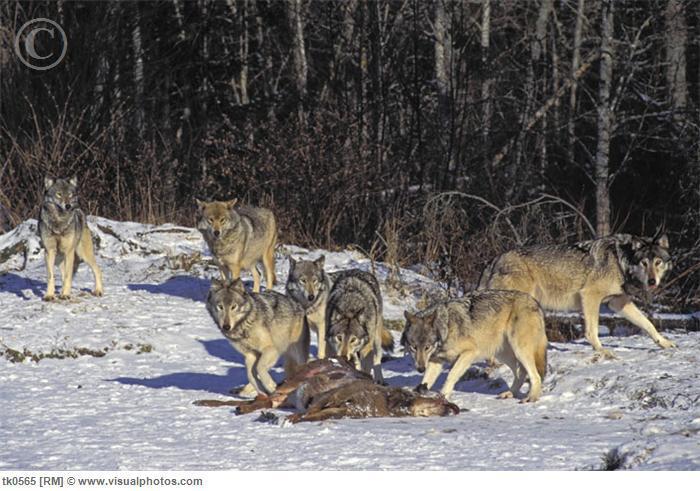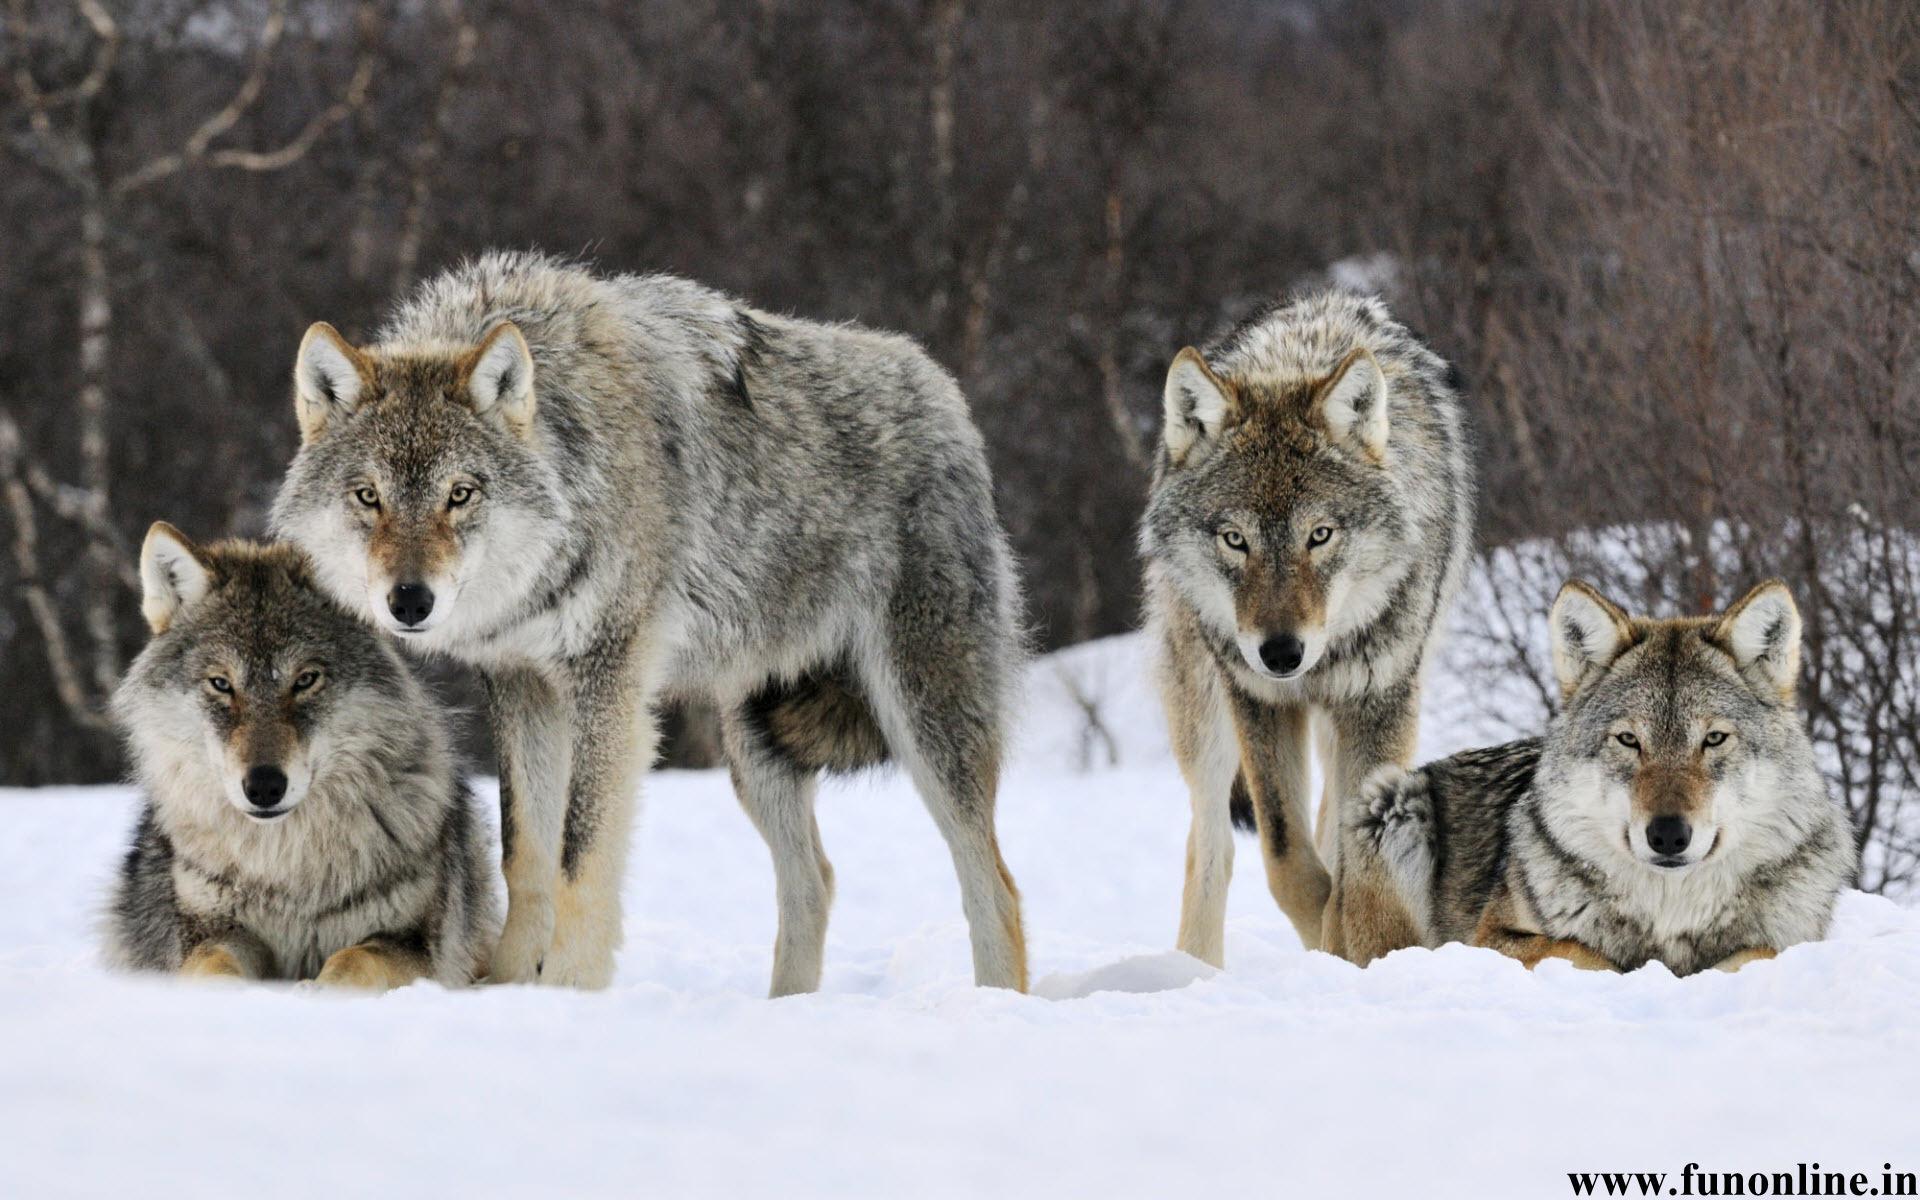The first image is the image on the left, the second image is the image on the right. Given the left and right images, does the statement "Each image shows at least three wolves in a snowy scene, and no carcass is visible in either scene." hold true? Answer yes or no. No. The first image is the image on the left, the second image is the image on the right. For the images displayed, is the sentence "There are more than six wolves." factually correct? Answer yes or no. Yes. 